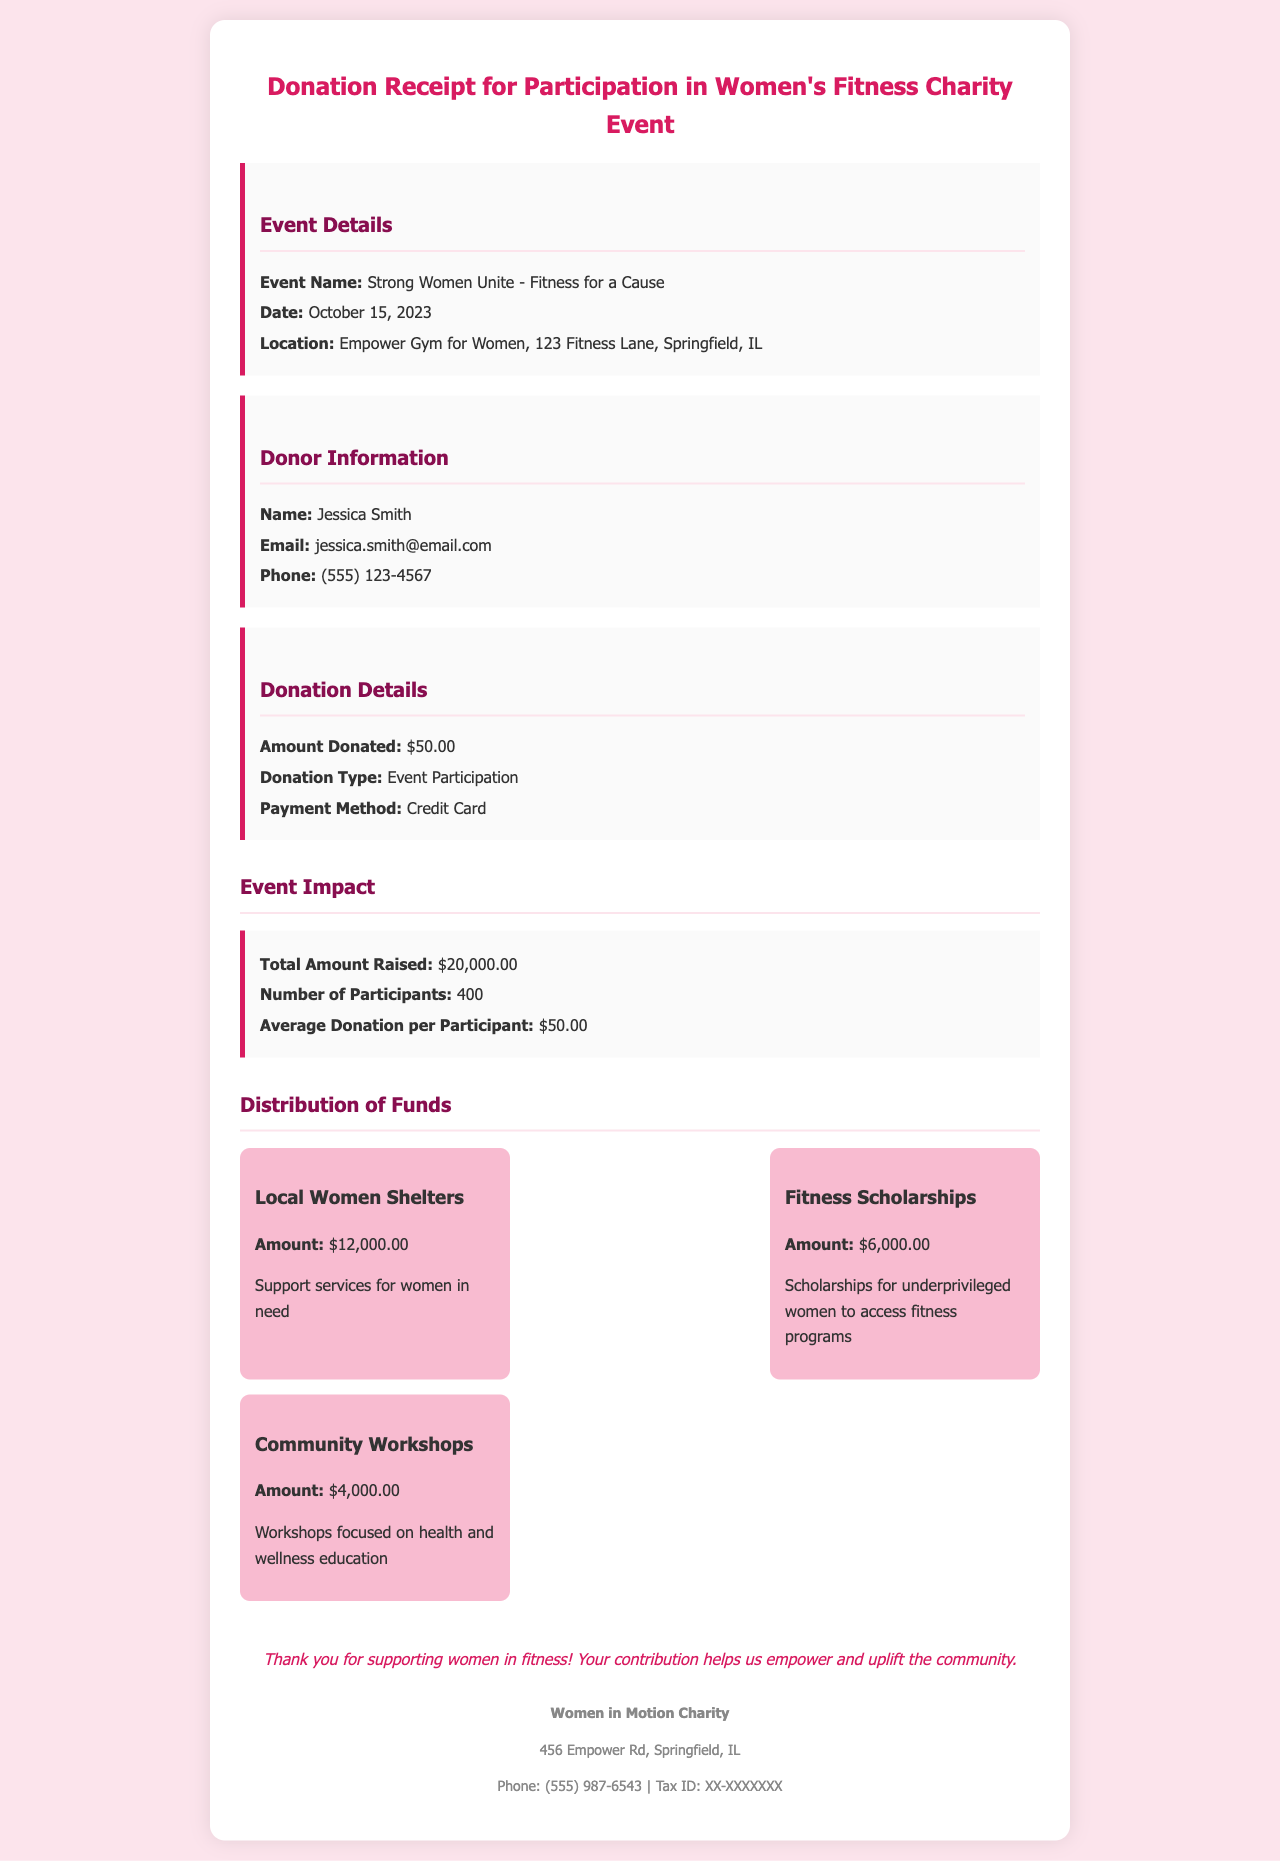what is the event name? The event name is stated in the document under event details.
Answer: Strong Women Unite - Fitness for a Cause when did the event take place? The date of the event is mentioned in the document under event details.
Answer: October 15, 2023 how much was donated in total? The total amount raised is detailed in the event impact section of the document.
Answer: $20,000.00 how many participants joined the event? The number of participants is provided in the event impact section.
Answer: 400 what percentage of the total funds was allocated to local women shelters? The amount allocated to local women shelters is represented among the fund distributions and is calculated as a fraction of the total amount raised.
Answer: 60% what is the purpose of the fitness scholarships? The purpose of the fitness scholarships is specified in the distribution section.
Answer: Scholarships for underprivileged women to access fitness programs who is the donor named in the receipt? The donor information includes the name of the individual who made the donation.
Answer: Jessica Smith what method of payment was used for the donation? The payment method for the donation is indicated in the donation details section of the document.
Answer: Credit Card what is the address of the charity organization? The address of the charity organization is listed in the footer of the document.
Answer: 456 Empower Rd, Springfield, IL 